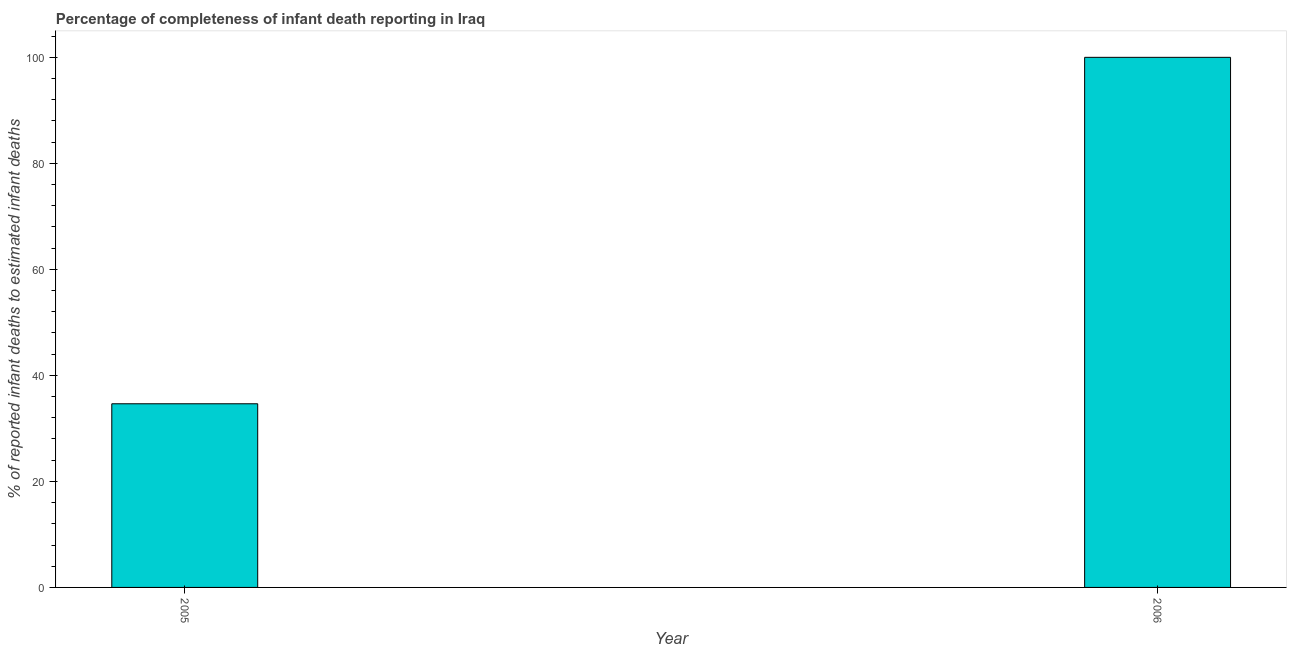Does the graph contain any zero values?
Make the answer very short. No. What is the title of the graph?
Your answer should be very brief. Percentage of completeness of infant death reporting in Iraq. What is the label or title of the Y-axis?
Offer a very short reply. % of reported infant deaths to estimated infant deaths. What is the completeness of infant death reporting in 2005?
Your answer should be very brief. 34.64. Across all years, what is the minimum completeness of infant death reporting?
Make the answer very short. 34.64. In which year was the completeness of infant death reporting maximum?
Your response must be concise. 2006. What is the sum of the completeness of infant death reporting?
Your response must be concise. 134.64. What is the difference between the completeness of infant death reporting in 2005 and 2006?
Provide a succinct answer. -65.36. What is the average completeness of infant death reporting per year?
Offer a very short reply. 67.32. What is the median completeness of infant death reporting?
Ensure brevity in your answer.  67.32. In how many years, is the completeness of infant death reporting greater than 76 %?
Provide a succinct answer. 1. Do a majority of the years between 2006 and 2005 (inclusive) have completeness of infant death reporting greater than 56 %?
Give a very brief answer. No. What is the ratio of the completeness of infant death reporting in 2005 to that in 2006?
Your response must be concise. 0.35. Is the completeness of infant death reporting in 2005 less than that in 2006?
Your response must be concise. Yes. Are all the bars in the graph horizontal?
Your answer should be compact. No. Are the values on the major ticks of Y-axis written in scientific E-notation?
Provide a short and direct response. No. What is the % of reported infant deaths to estimated infant deaths of 2005?
Provide a succinct answer. 34.64. What is the % of reported infant deaths to estimated infant deaths in 2006?
Provide a short and direct response. 100. What is the difference between the % of reported infant deaths to estimated infant deaths in 2005 and 2006?
Offer a terse response. -65.36. What is the ratio of the % of reported infant deaths to estimated infant deaths in 2005 to that in 2006?
Make the answer very short. 0.35. 